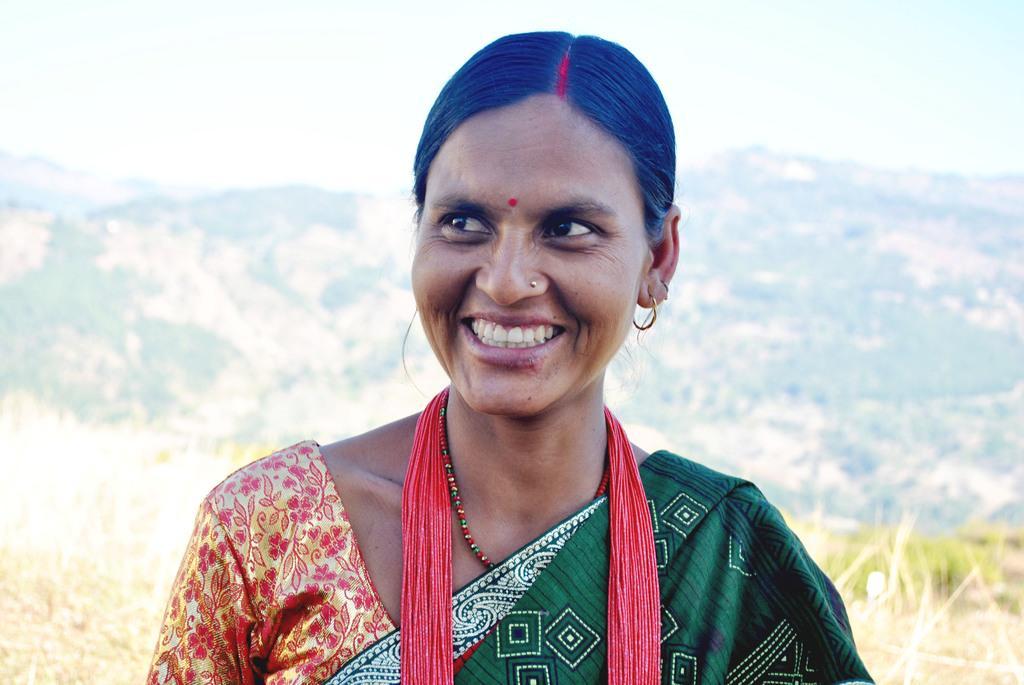How would you summarize this image in a sentence or two? In this image we can see a woman and in the background there is a grass, mountains and the sky. 